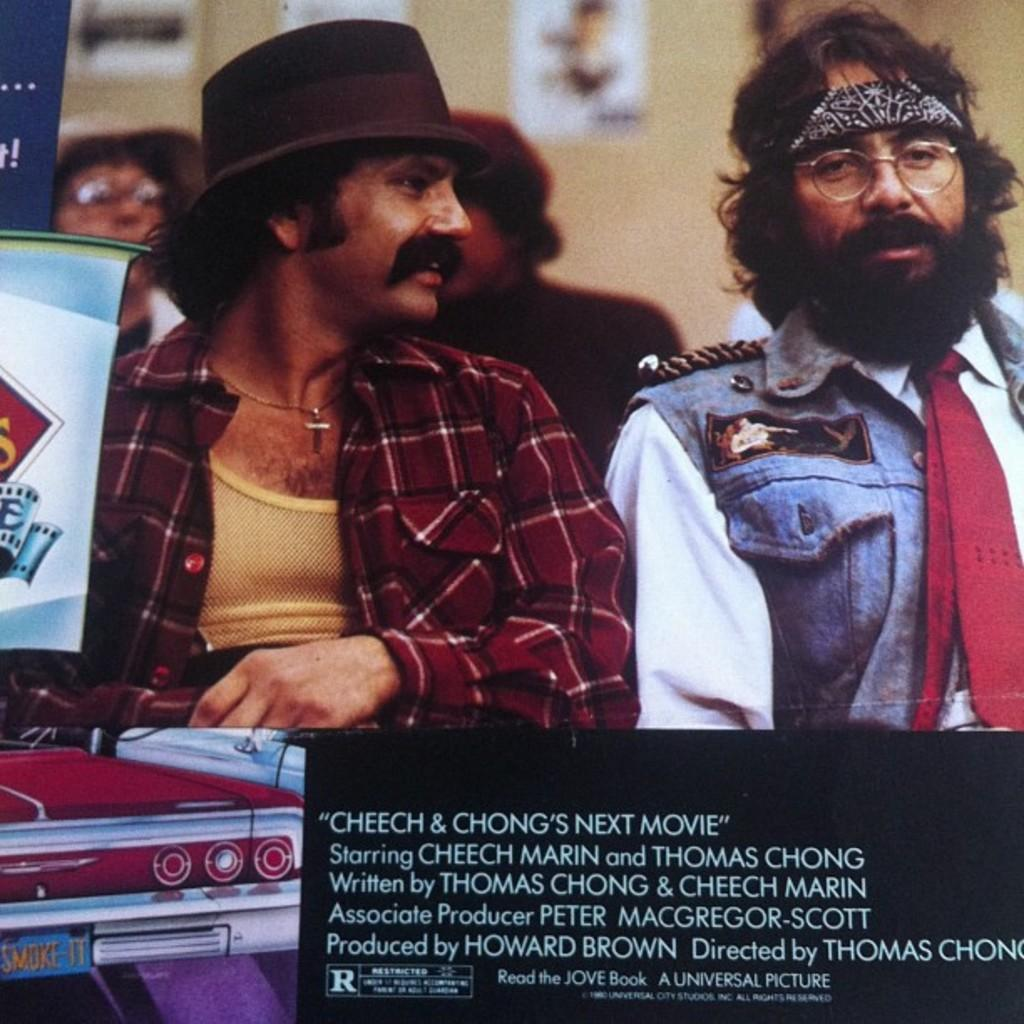Who or what can be seen in the image? There are people in the image. What are the people interacting with in the image? There are objects in front of the people. What can be seen on the wall in the background? There is a wall with posters on it in the background. Where is the text located in the image? There is some text on the right side of the image. What type of plantation can be seen in the image? There is no plantation present in the image. How does the image promote peace? The image does not specifically promote peace; it simply shows people interacting with objects and a wall with posters in the background. 